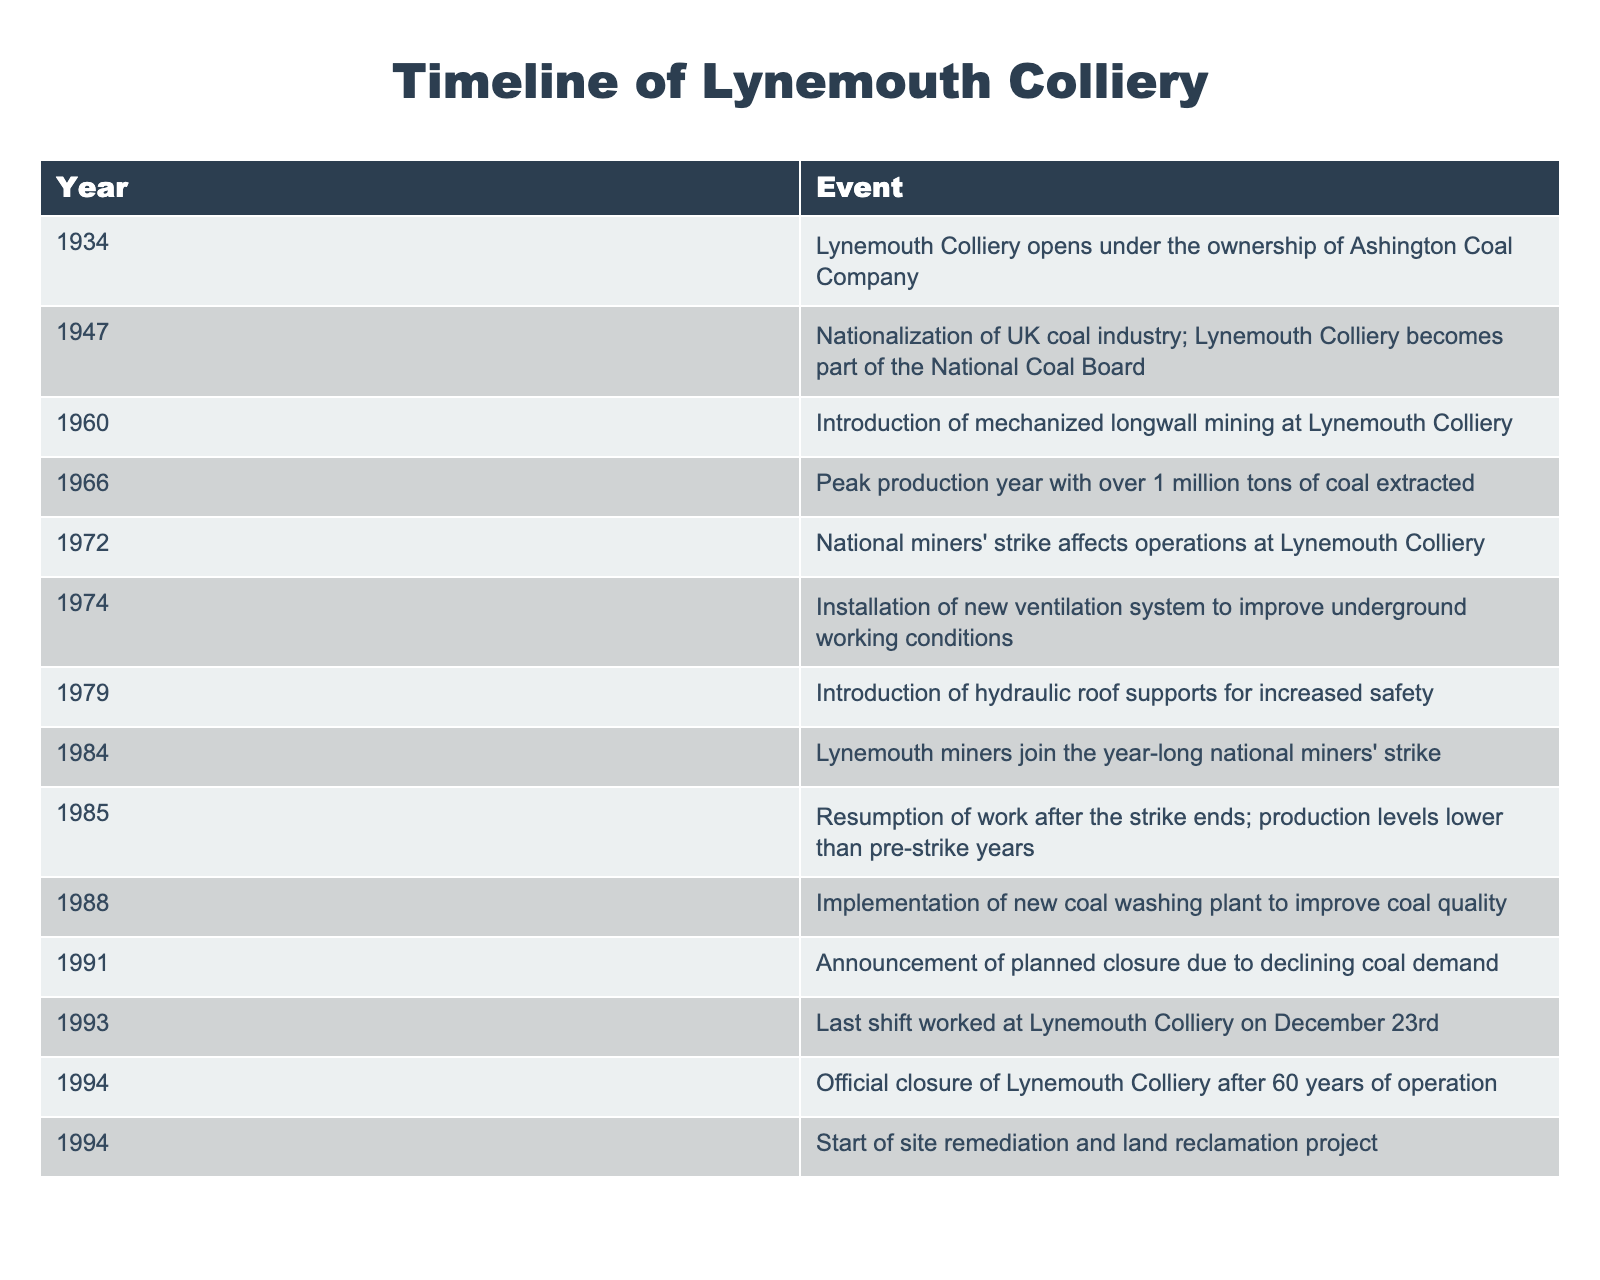What year did Lynemouth Colliery open? The table shows that Lynemouth Colliery opened in the year 1934. Since this information is directly stated in the first row of the table, I retrieved it easily.
Answer: 1934 What event occurred in 1966? Looking at the table, the event listed for the year 1966 is the peak production year, where over 1 million tons of coal were extracted from Lynemouth Colliery. This can be found in the corresponding row for that year.
Answer: Peak production year with over 1 million tons of coal extracted How many years did Lynemouth Colliery operate before its official closure? The colliery opened in 1934 and officially closed in 1994. To find the number of years it operated, I subtract the opening year from the closure year: 1994 - 1934 = 60 years.
Answer: 60 years Did Lynemouth Colliery participate in strikes during the 1980s? The table reveals that Lynemouth miners joined a year-long national miners' strike in 1984. This indicates participation in strikes during the 1980s. Additionally, the event in 1985 confirms that they resumed work after the strike ended, supporting the answer.
Answer: Yes What major changes occurred at Lynemouth Colliery between 1960 and 1988? From 1960 to 1988, the colliery saw several major developments: the introduction of mechanized longwall mining in 1960, the peak production year in 1966, the introduction of hydraulic roof supports in 1979, and the implementation of a new coal washing plant in 1988. I compiled these events as they all represent significant changes to operations during this period.
Answer: Mechanized mining, peak production, hydraulic supports, coal washing plant When was the new ventilation system installed, and why was it crucial? The new ventilation system was installed in 1974 to improve underground working conditions. This is noted in the relevant row of the table. Such improvements are crucial for ensuring the safety and health of miners working underground.
Answer: 1974, to improve underground working conditions What happened to Lynemouth Colliery immediately after the national miners' strike in 1984? According to the table, after the miners' strike ended in 1985, work resumed. However, production levels were lower than those before the strike. This sequence of events illustrates a decline following the strike.
Answer: Resumption of work, lower production levels How many years passed between the announcement of planned closure and the official closure of the colliery? The announcement of the planned closure was made in 1991, and the official closure occurred in 1994. To calculate the time between these two events, I subtract 1991 from 1994: 1994 - 1991 = 3 years.
Answer: 3 years 